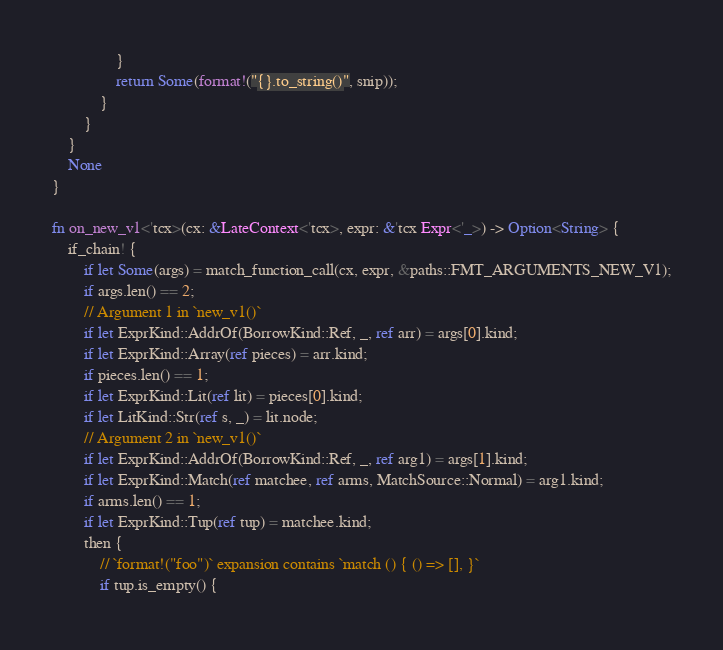Convert code to text. <code><loc_0><loc_0><loc_500><loc_500><_Rust_>                }
                return Some(format!("{}.to_string()", snip));
            }
        }
    }
    None
}

fn on_new_v1<'tcx>(cx: &LateContext<'tcx>, expr: &'tcx Expr<'_>) -> Option<String> {
    if_chain! {
        if let Some(args) = match_function_call(cx, expr, &paths::FMT_ARGUMENTS_NEW_V1);
        if args.len() == 2;
        // Argument 1 in `new_v1()`
        if let ExprKind::AddrOf(BorrowKind::Ref, _, ref arr) = args[0].kind;
        if let ExprKind::Array(ref pieces) = arr.kind;
        if pieces.len() == 1;
        if let ExprKind::Lit(ref lit) = pieces[0].kind;
        if let LitKind::Str(ref s, _) = lit.node;
        // Argument 2 in `new_v1()`
        if let ExprKind::AddrOf(BorrowKind::Ref, _, ref arg1) = args[1].kind;
        if let ExprKind::Match(ref matchee, ref arms, MatchSource::Normal) = arg1.kind;
        if arms.len() == 1;
        if let ExprKind::Tup(ref tup) = matchee.kind;
        then {
            // `format!("foo")` expansion contains `match () { () => [], }`
            if tup.is_empty() {</code> 